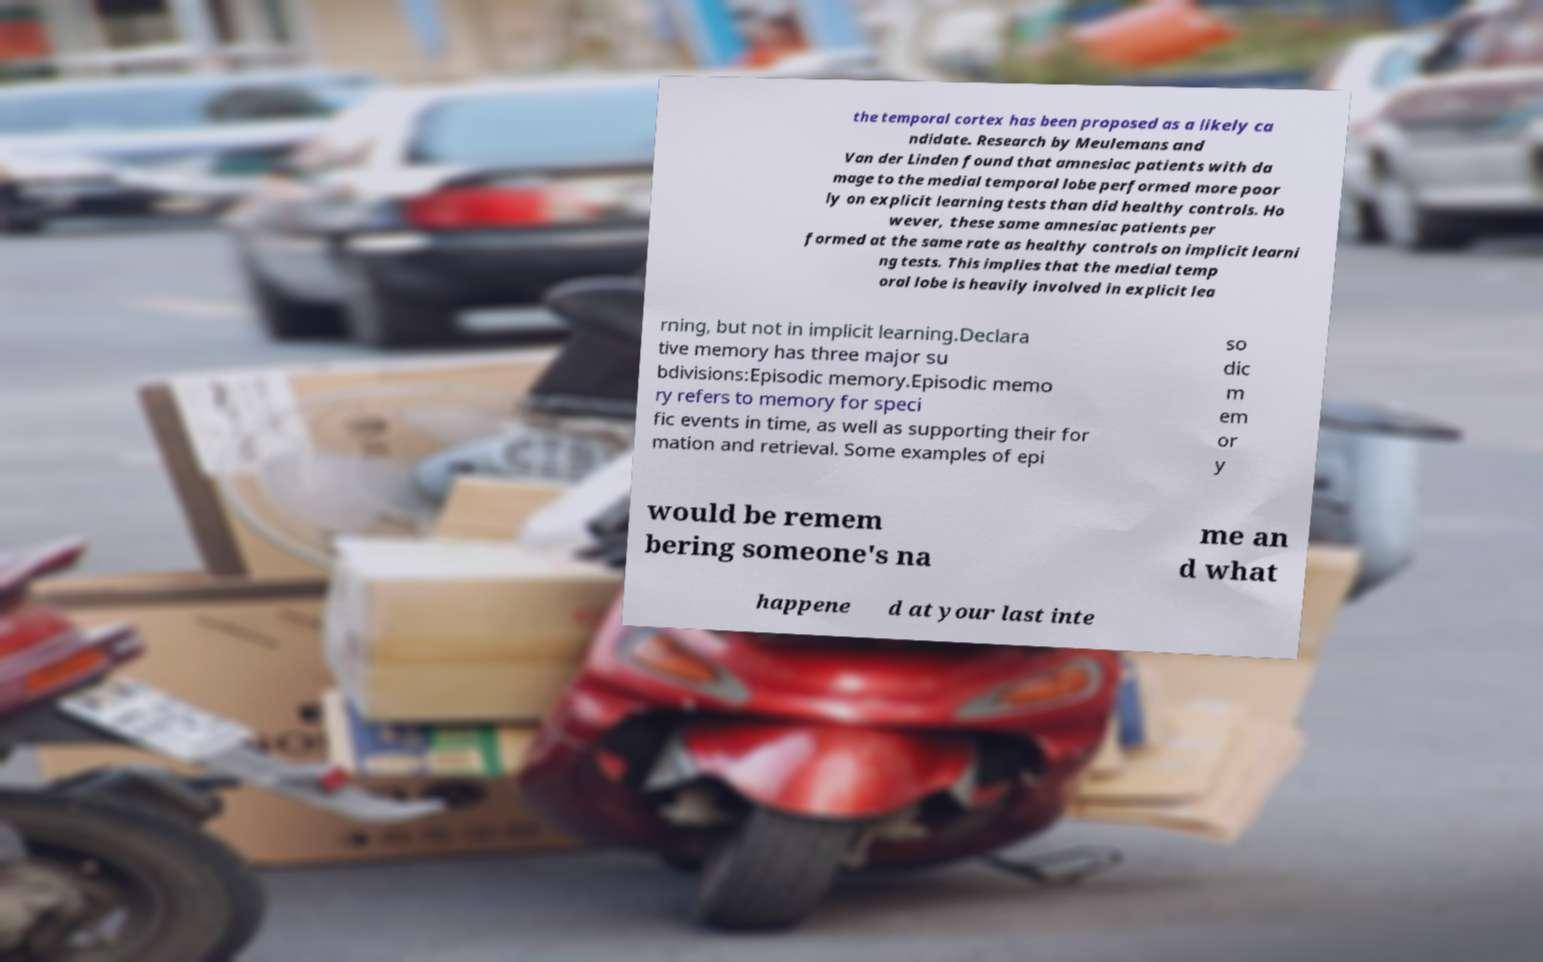Please identify and transcribe the text found in this image. the temporal cortex has been proposed as a likely ca ndidate. Research by Meulemans and Van der Linden found that amnesiac patients with da mage to the medial temporal lobe performed more poor ly on explicit learning tests than did healthy controls. Ho wever, these same amnesiac patients per formed at the same rate as healthy controls on implicit learni ng tests. This implies that the medial temp oral lobe is heavily involved in explicit lea rning, but not in implicit learning.Declara tive memory has three major su bdivisions:Episodic memory.Episodic memo ry refers to memory for speci fic events in time, as well as supporting their for mation and retrieval. Some examples of epi so dic m em or y would be remem bering someone's na me an d what happene d at your last inte 